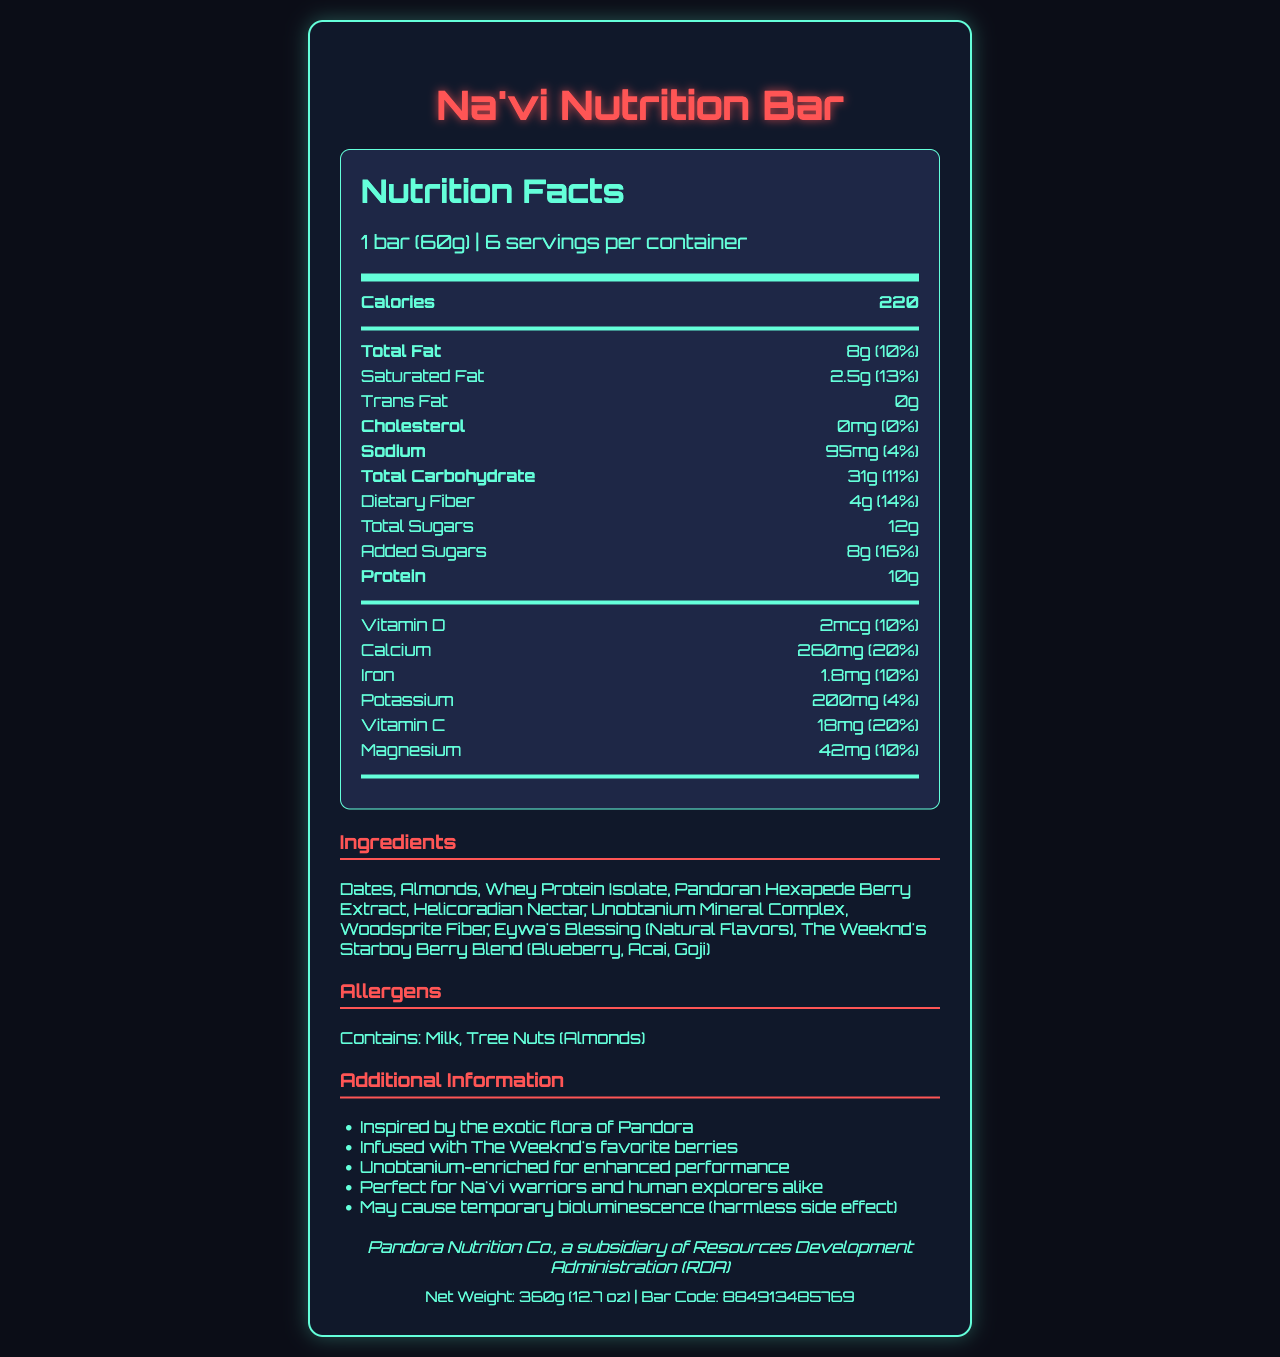what is the serving size of the Na'vi Nutrition Bar? The serving size is located near the top of the nutrition facts, under the product name.
Answer: 1 bar (60g) how many servings are in one container? The number of servings per container is listed near the top of the nutrition facts.
Answer: 6 how many calories are in one bar? The calorie content is prominently displayed towards the top of the nutrition facts section.
Answer: 220 how much total fat is in each bar? The total fat amount is indicated under the nutrition information.
Answer: 8g what is the main natural flavoring in the Na'vi Nutrition Bar? The main natural flavoring is listed in the ingredients section.
Answer: Eywa's Blessing (Natural Flavors) how much protein does each bar contain? The protein content is listed under the nutrition information.
Answer: 10g which of the following vitamins is highest in quantity in each bar of the Na'vi Nutrition Bar? A. Vitamin D B. Calcium C. Vitamin C Calcium has 260mg which is 20% of the daily value, the highest among the listed vitamins.
Answer: B. Calcium what exotic Pandoran ingredient is included in the Na'vi Nutrition Bar? A. Helicoradian Nectar B. Eywa's Blessing C. The Weeknd's Starboy Berry Blend Helicoradian Nectar is a unique Pandoran ingredient and is listed in the ingredients.
Answer: A. Helicoradian Nectar does the Na'vi Nutrition Bar contain any trans fat? The nutrition information specifies that it contains 0g of trans fat.
Answer: No describe the main features and nutritional highlights of the Na'vi Nutrition Bar. The main features include the connection to Pandora and The Weeknd, along with the breakdown of calories, fats, proteins, ingredients, vitamins, and minerals.
Answer: The Na'vi Nutrition Bar is inspired by the flora of Pandora and infused with The Weeknd's favorite berries. Each bar is 60g and there are 6 servings per container. It contains 220 calories, 8g of total fat, 10g of protein, and is enriched with a variety of vitamins and minerals. Its ingredients include unique elements like Pandoran Hexapede Berry Extract and Unobtanium Mineral Complex. what is the total carbohydrate content in the Na'vi Nutrition Bar? The total carbohydrate content is listed under the nutrition information.
Answer: 31g how much Vitamin D does each bar provide in terms of daily value percentage? The Vitamin D content is 2mcg, equating to 10% of the daily value.
Answer: 10% what is the allergen information for the Na'vi Nutrition Bar? The allergen information is clearly listed under the allergens section.
Answer: Contains: Milk, Tree Nuts (Almonds) who manufactures the Na'vi Nutrition Bar? The manufacturer information is found at the bottom of the document.
Answer: Pandora Nutrition Co., a subsidiary of Resources Development Administration (RDA) how much Vitamin C is in each bar? The Vitamin C content is listed under the nutrition information and amounts to 18mg.
Answer: 18mg does the Na'vi Nutrition Bar contain Unobtanium? Unobtanium Mineral Complex is listed as one of the ingredients.
Answer: Yes what is the net weight of the package containing the Na'vi Nutrition Bars? The net weight is mentioned at the bottom of the document along with the bar code.
Answer: 360g (12.7 oz) what inspired the creation of the Na'vi Nutrition Bar? The additional information section mentions that the bar was inspired by the exotic flora of Pandora.
Answer: Inspired by the exotic flora of Pandora which of the following is a side effect of the Na'vi Nutrition Bar? A. Increased energy B. Weight loss C. Temporary bioluminescence The additional information section states that the bar may cause temporary bioluminescence, which is a harmless side effect.
Answer: C. Temporary bioluminescence how does the Na'vi Nutrition Bar enhance performance? The additional info section mentions that Unobtanium-enriched is for enhanced performance.
Answer: Enriched with Unobtanium what is the sodium content in each bar? The sodium content is listed under the nutrition information.
Answer: 95mg what year was the Na'vi Nutrition Bar introduced? The visual document does not provide any information about the year of introduction.
Answer: Cannot be determined 